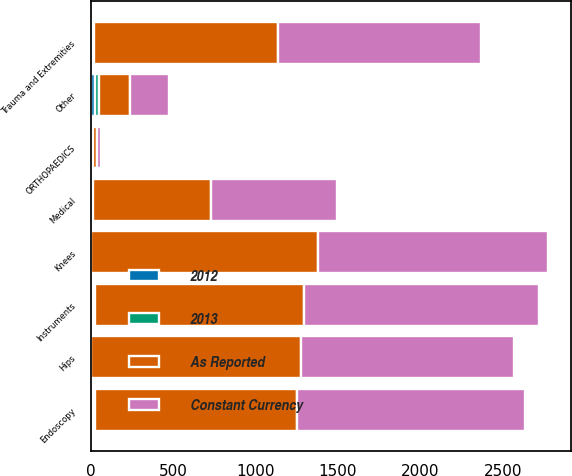<chart> <loc_0><loc_0><loc_500><loc_500><stacked_bar_chart><ecel><fcel>Knees<fcel>Hips<fcel>Trauma and Extremities<fcel>Other<fcel>ORTHOPAEDICS<fcel>Instruments<fcel>Endoscopy<fcel>Medical<nl><fcel>Constant Currency<fcel>1396<fcel>1291<fcel>1230<fcel>236<fcel>24.6<fcel>1424<fcel>1382<fcel>766<nl><fcel>As Reported<fcel>1371<fcel>1272<fcel>1116<fcel>190<fcel>24.6<fcel>1269<fcel>1222<fcel>710<nl><fcel>2012<fcel>1.8<fcel>1.5<fcel>10.2<fcel>24<fcel>5.2<fcel>12.2<fcel>13.1<fcel>7.9<nl><fcel>2013<fcel>2.7<fcel>2.7<fcel>11.4<fcel>25.2<fcel>6.3<fcel>13.1<fcel>14.2<fcel>8.8<nl></chart> 